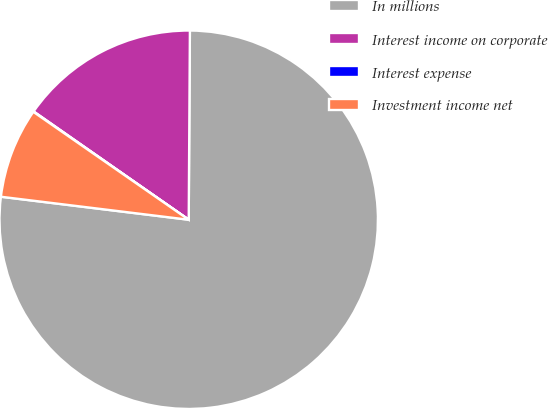Convert chart to OTSL. <chart><loc_0><loc_0><loc_500><loc_500><pie_chart><fcel>In millions<fcel>Interest income on corporate<fcel>Interest expense<fcel>Investment income net<nl><fcel>76.84%<fcel>15.4%<fcel>0.04%<fcel>7.72%<nl></chart> 